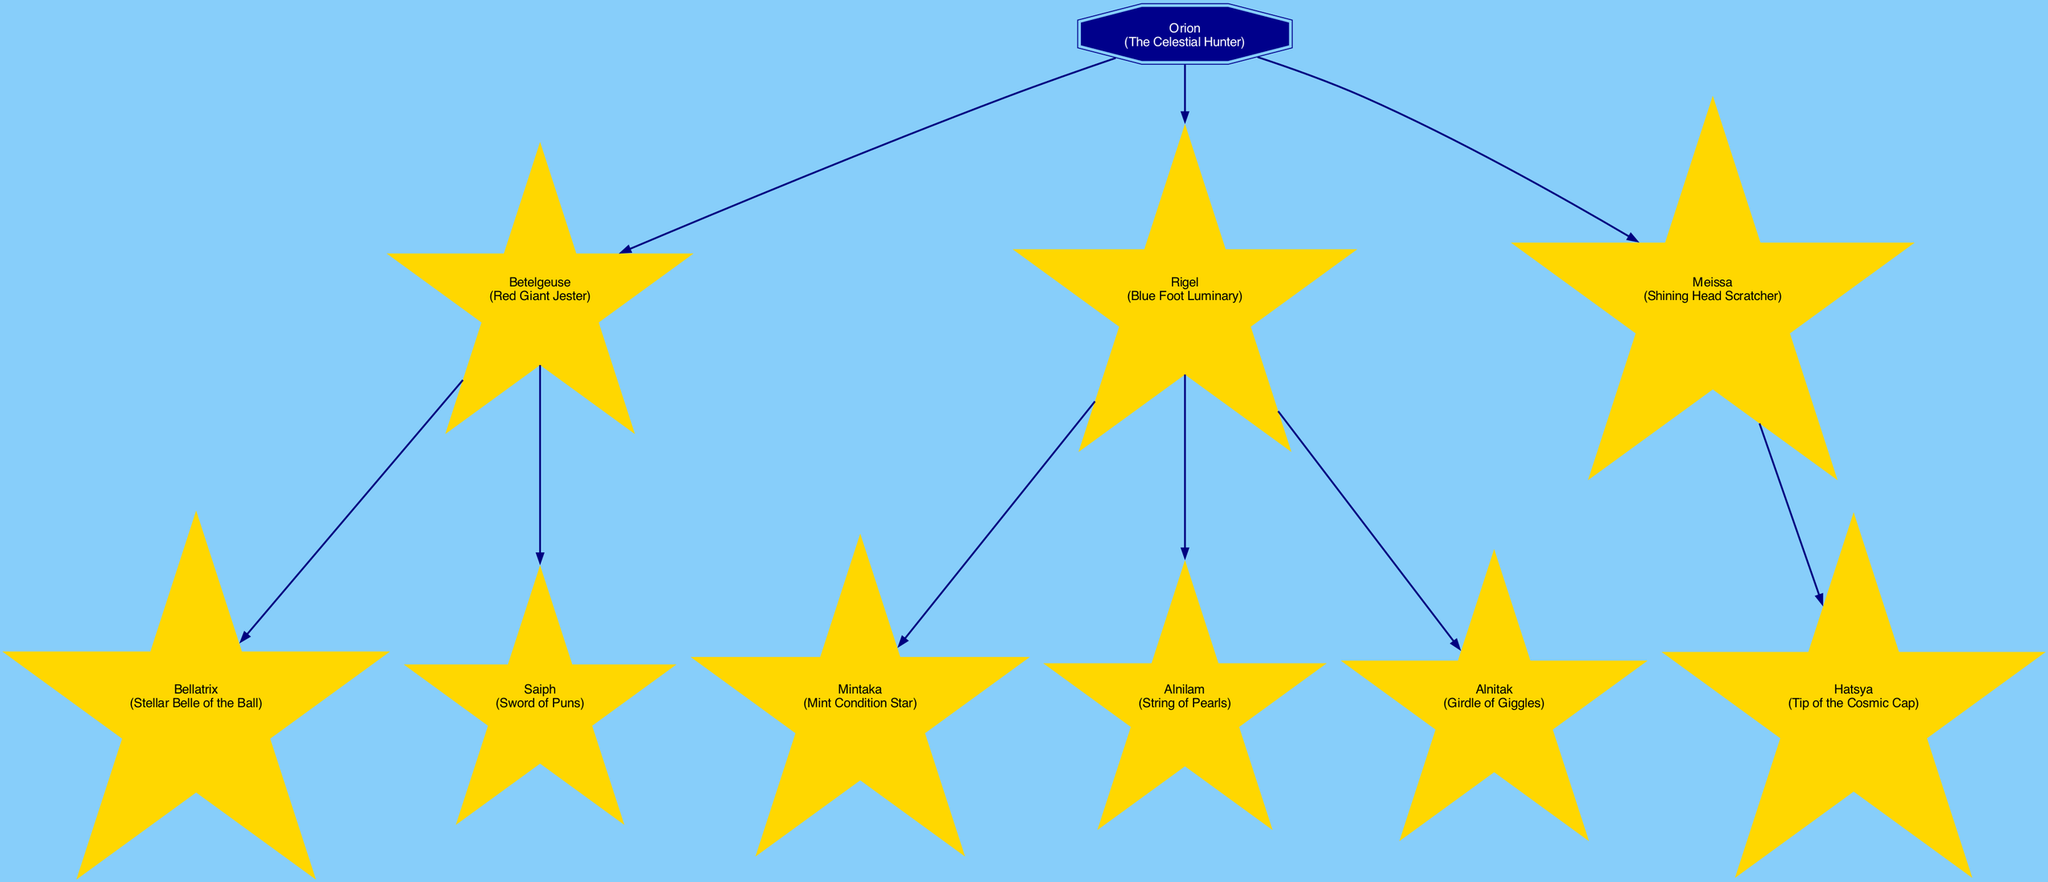What is the nickname of Betelgeuse? The diagram indicates that Betelgeuse has the nickname "Red Giant Jester." It is directly listed under its name.
Answer: Red Giant Jester How many children does Rigel have? By examining the diagram, Rigel is shown to have three children: Mintaka, Alnilam, and Alnitak. Therefore, the total count is 3.
Answer: 3 Who is the parent of Saiph? The diagram shows that Saiph is a child of Betelgeuse. The relationship can be traced directly from the diagram where Saiph is listed under Betelgeuse.
Answer: Betelgeuse What is the nickname of Alnitak? According to the diagram, Alnitak is referred to as "Girdle of Giggles." This nickname appears directly associated with Alnitak in the family tree.
Answer: Girdle of Giggles Which star is known as the "Tip of the Cosmic Cap"? Looking at the family tree, Hatsya is identified as "Tip of the Cosmic Cap," showing its association with Meissa, its parent star.
Answer: Hatsya What is the total number of celestial bodies in the Orion family tree? Counting the nodes displayed in the diagram, we find that there are a total of 8 celestial bodies: Orion (the root), Betelgeuse, Rigel, Meissa, and their respective children.
Answer: 8 Which star resides at the top of the family tree? The diagram clearly identifies Orion as the root node, indicating that it occupies the highest position in the family structure of the diagram.
Answer: Orion How many children does Meissa have? By looking at the family tree, Meissa has one child, Hatsya. This relationship is straightforward as Hatsya is noted directly under Meissa.
Answer: 1 What nickname is shared between Bellatrix and Alnilam? Observing the nicknames in the diagram, we note that neither Bellatrix nor Alnilam shares a nickname; they each have unique ones: "Stellar Belle of the Ball" and "String of Pearls," respectively. Thus, the answer is that they share none.
Answer: None 